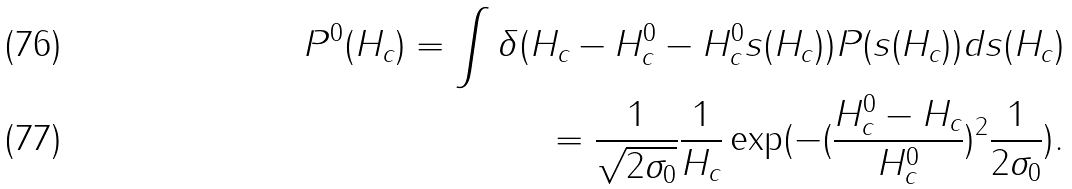<formula> <loc_0><loc_0><loc_500><loc_500>P ^ { 0 } ( H _ { c } ) = \int \delta ( { H _ { c } - H ^ { 0 } _ { c } } - { H ^ { 0 } _ { c } } s ( H _ { c } ) ) P ( s ( H _ { c } ) ) d s ( H _ { c } ) \\ = \frac { 1 } { \sqrt { 2 \sigma _ { 0 } } } \frac { 1 } { H _ { c } } \exp ( - ( \frac { H ^ { 0 } _ { c } - H _ { c } } { H ^ { 0 } _ { c } } ) ^ { 2 } \frac { 1 } { 2 \sigma _ { 0 } } ) .</formula> 